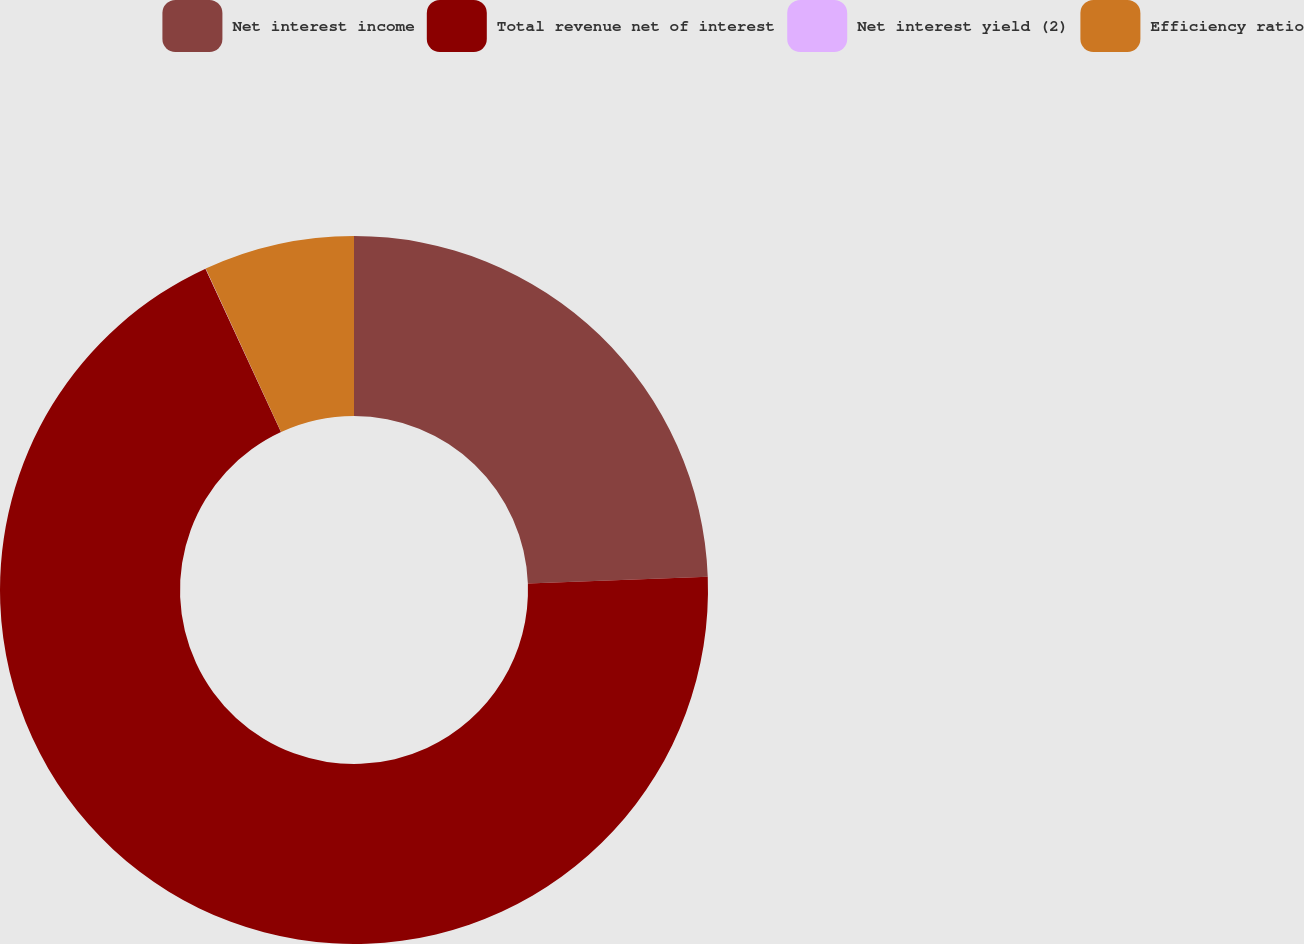<chart> <loc_0><loc_0><loc_500><loc_500><pie_chart><fcel>Net interest income<fcel>Total revenue net of interest<fcel>Net interest yield (2)<fcel>Efficiency ratio<nl><fcel>24.41%<fcel>68.71%<fcel>0.01%<fcel>6.88%<nl></chart> 